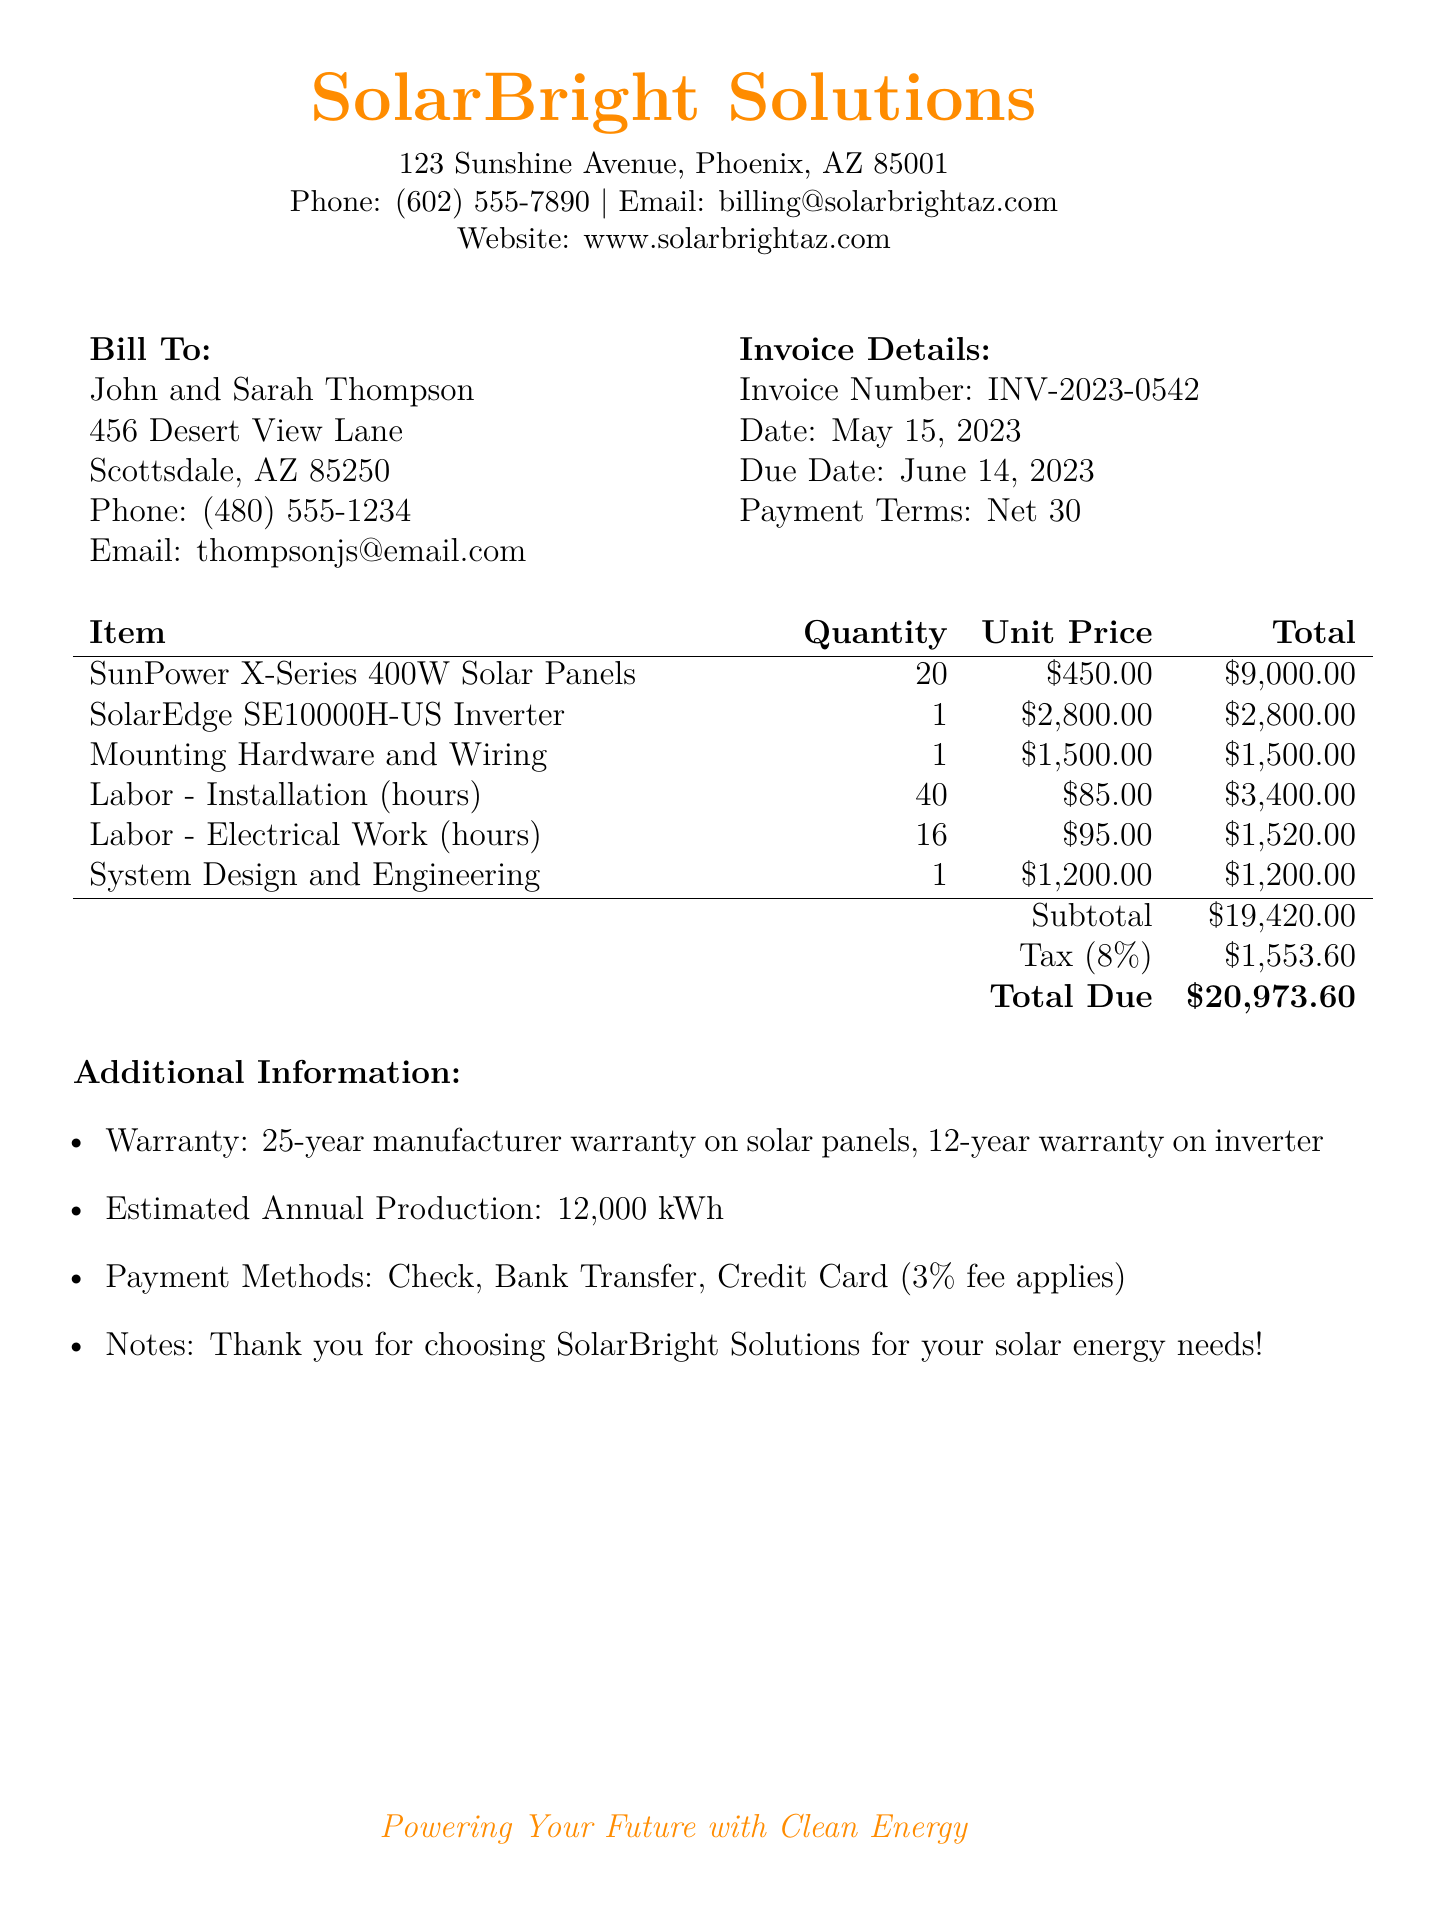What is the invoice number? The invoice number is a unique identifier for the bill, which is shown in the document.
Answer: INV-2023-0542 What is the due date for this invoice? The due date is the date by which payment should be made, listed in the invoice details.
Answer: June 14, 2023 How many solar panels are included in the installation? The quantity of solar panels installed is mentioned in the itemized list of the bill.
Answer: 20 What is the total amount of tax charged? The tax amount is calculated as a percentage of the subtotal, shown in the total section of the invoice.
Answer: $1,553.60 How much was charged for labor installation hours? The total for labor installation is itemized in the labor costs section of the document.
Answer: $3,400.00 What is the subtotal before tax and total due? The subtotal is the sum of itemized costs before tax, while the total due is after tax.
Answer: Subtotal: $19,420.00; Total Due: $20,973.60 What warranty is provided on the solar panels? The warranty for the solar panels is stated in the additional information section of the document.
Answer: 25-year manufacturer warranty What payment methods are mentioned? The document specifies the acceptable payment methods for the invoice in the additional information section.
Answer: Check, Bank Transfer, Credit Card What product is identified as the inverter? The inverter model is specifically listed among the installed equipment in the itemized bill.
Answer: SolarEdge SE10000H-US Inverter 